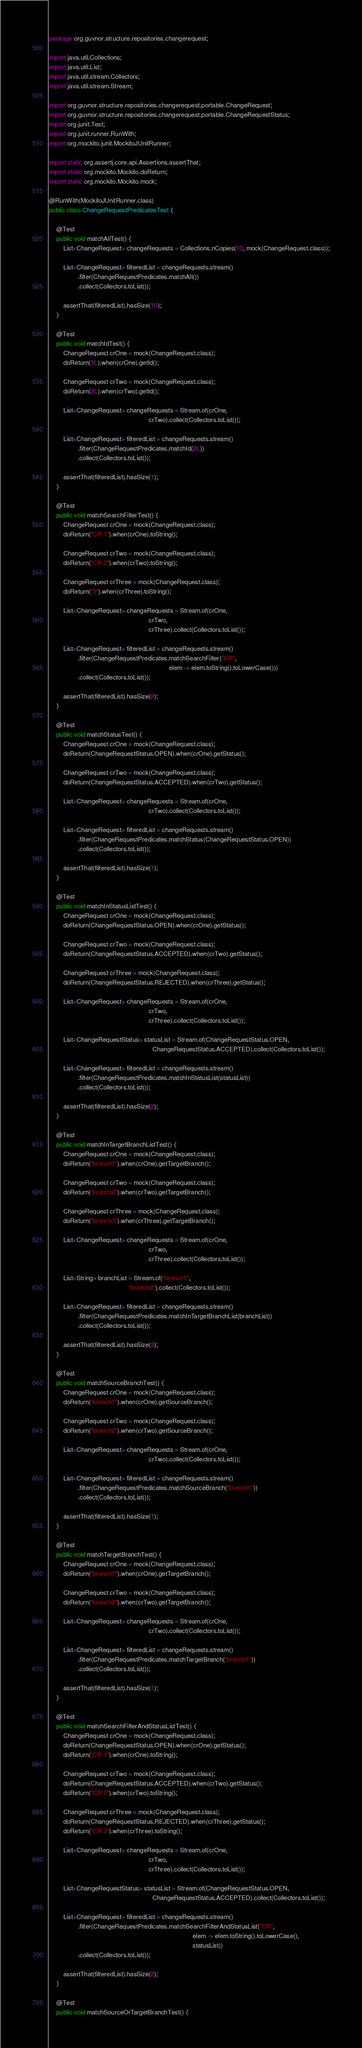Convert code to text. <code><loc_0><loc_0><loc_500><loc_500><_Java_>package org.guvnor.structure.repositories.changerequest;

import java.util.Collections;
import java.util.List;
import java.util.stream.Collectors;
import java.util.stream.Stream;

import org.guvnor.structure.repositories.changerequest.portable.ChangeRequest;
import org.guvnor.structure.repositories.changerequest.portable.ChangeRequestStatus;
import org.junit.Test;
import org.junit.runner.RunWith;
import org.mockito.junit.MockitoJUnitRunner;

import static org.assertj.core.api.Assertions.assertThat;
import static org.mockito.Mockito.doReturn;
import static org.mockito.Mockito.mock;

@RunWith(MockitoJUnitRunner.class)
public class ChangeRequestPredicatesTest {

    @Test
    public void matchAllTest() {
        List<ChangeRequest> changeRequests = Collections.nCopies(10, mock(ChangeRequest.class));

        List<ChangeRequest> filteredList = changeRequests.stream()
                .filter(ChangeRequestPredicates.matchAll())
                .collect(Collectors.toList());

        assertThat(filteredList).hasSize(10);
    }

    @Test
    public void matchIdTest() {
        ChangeRequest crOne = mock(ChangeRequest.class);
        doReturn(1L).when(crOne).getId();

        ChangeRequest crTwo = mock(ChangeRequest.class);
        doReturn(2L).when(crTwo).getId();

        List<ChangeRequest> changeRequests = Stream.of(crOne,
                                                       crTwo).collect(Collectors.toList());

        List<ChangeRequest> filteredList = changeRequests.stream()
                .filter(ChangeRequestPredicates.matchId(2L))
                .collect(Collectors.toList());

        assertThat(filteredList).hasSize(1);
    }

    @Test
    public void matchSearchFilterTest() {
        ChangeRequest crOne = mock(ChangeRequest.class);
        doReturn("CR 1").when(crOne).toString();

        ChangeRequest crTwo = mock(ChangeRequest.class);
        doReturn("CR 2").when(crTwo).toString();

        ChangeRequest crThree = mock(ChangeRequest.class);
        doReturn("3").when(crThree).toString();

        List<ChangeRequest> changeRequests = Stream.of(crOne,
                                                       crTwo,
                                                       crThree).collect(Collectors.toList());

        List<ChangeRequest> filteredList = changeRequests.stream()
                .filter(ChangeRequestPredicates.matchSearchFilter("CR",
                                                                  elem -> elem.toString().toLowerCase()))
                .collect(Collectors.toList());

        assertThat(filteredList).hasSize(2);
    }

    @Test
    public void matchStatusTest() {
        ChangeRequest crOne = mock(ChangeRequest.class);
        doReturn(ChangeRequestStatus.OPEN).when(crOne).getStatus();

        ChangeRequest crTwo = mock(ChangeRequest.class);
        doReturn(ChangeRequestStatus.ACCEPTED).when(crTwo).getStatus();

        List<ChangeRequest> changeRequests = Stream.of(crOne,
                                                       crTwo).collect(Collectors.toList());

        List<ChangeRequest> filteredList = changeRequests.stream()
                .filter(ChangeRequestPredicates.matchStatus(ChangeRequestStatus.OPEN))
                .collect(Collectors.toList());

        assertThat(filteredList).hasSize(1);
    }

    @Test
    public void matchInStatusListTest() {
        ChangeRequest crOne = mock(ChangeRequest.class);
        doReturn(ChangeRequestStatus.OPEN).when(crOne).getStatus();

        ChangeRequest crTwo = mock(ChangeRequest.class);
        doReturn(ChangeRequestStatus.ACCEPTED).when(crTwo).getStatus();

        ChangeRequest crThree = mock(ChangeRequest.class);
        doReturn(ChangeRequestStatus.REJECTED).when(crThree).getStatus();

        List<ChangeRequest> changeRequests = Stream.of(crOne,
                                                       crTwo,
                                                       crThree).collect(Collectors.toList());

        List<ChangeRequestStatus> statusList = Stream.of(ChangeRequestStatus.OPEN,
                                                         ChangeRequestStatus.ACCEPTED).collect(Collectors.toList());

        List<ChangeRequest> filteredList = changeRequests.stream()
                .filter(ChangeRequestPredicates.matchInStatusList(statusList))
                .collect(Collectors.toList());

        assertThat(filteredList).hasSize(2);
    }

    @Test
    public void matchInTargetBranchListTest() {
        ChangeRequest crOne = mock(ChangeRequest.class);
        doReturn("branch1").when(crOne).getTargetBranch();

        ChangeRequest crTwo = mock(ChangeRequest.class);
        doReturn("branch2").when(crTwo).getTargetBranch();

        ChangeRequest crThree = mock(ChangeRequest.class);
        doReturn("branch3").when(crThree).getTargetBranch();

        List<ChangeRequest> changeRequests = Stream.of(crOne,
                                                       crTwo,
                                                       crThree).collect(Collectors.toList());

        List<String> branchList = Stream.of("branch1",
                                            "branch2").collect(Collectors.toList());

        List<ChangeRequest> filteredList = changeRequests.stream()
                .filter(ChangeRequestPredicates.matchInTargetBranchList(branchList))
                .collect(Collectors.toList());

        assertThat(filteredList).hasSize(2);
    }

    @Test
    public void matchSourceBranchTest() {
        ChangeRequest crOne = mock(ChangeRequest.class);
        doReturn("branch1").when(crOne).getSourceBranch();

        ChangeRequest crTwo = mock(ChangeRequest.class);
        doReturn("branch2").when(crTwo).getSourceBranch();

        List<ChangeRequest> changeRequests = Stream.of(crOne,
                                                       crTwo).collect(Collectors.toList());

        List<ChangeRequest> filteredList = changeRequests.stream()
                .filter(ChangeRequestPredicates.matchSourceBranch("branch1"))
                .collect(Collectors.toList());

        assertThat(filteredList).hasSize(1);
    }

    @Test
    public void matchTargetBranchTest() {
        ChangeRequest crOne = mock(ChangeRequest.class);
        doReturn("branch1").when(crOne).getTargetBranch();

        ChangeRequest crTwo = mock(ChangeRequest.class);
        doReturn("branch2").when(crTwo).getTargetBranch();

        List<ChangeRequest> changeRequests = Stream.of(crOne,
                                                       crTwo).collect(Collectors.toList());

        List<ChangeRequest> filteredList = changeRequests.stream()
                .filter(ChangeRequestPredicates.matchTargetBranch("branch1"))
                .collect(Collectors.toList());

        assertThat(filteredList).hasSize(1);
    }

    @Test
    public void matchSearchFilterAndStatusListTest() {
        ChangeRequest crOne = mock(ChangeRequest.class);
        doReturn(ChangeRequestStatus.OPEN).when(crOne).getStatus();
        doReturn("CR 1").when(crOne).toString();

        ChangeRequest crTwo = mock(ChangeRequest.class);
        doReturn(ChangeRequestStatus.ACCEPTED).when(crTwo).getStatus();
        doReturn("CR 2").when(crTwo).toString();

        ChangeRequest crThree = mock(ChangeRequest.class);
        doReturn(ChangeRequestStatus.REJECTED).when(crThree).getStatus();
        doReturn("CR 3").when(crThree).toString();

        List<ChangeRequest> changeRequests = Stream.of(crOne,
                                                       crTwo,
                                                       crThree).collect(Collectors.toList());

        List<ChangeRequestStatus> statusList = Stream.of(ChangeRequestStatus.OPEN,
                                                         ChangeRequestStatus.ACCEPTED).collect(Collectors.toList());

        List<ChangeRequest> filteredList = changeRequests.stream()
                .filter(ChangeRequestPredicates.matchSearchFilterAndStatusList("CR",
                                                                               elem -> elem.toString().toLowerCase(),
                                                                               statusList))
                .collect(Collectors.toList());

        assertThat(filteredList).hasSize(2);
    }

    @Test
    public void matchSourceOrTargetBranchTest() {</code> 